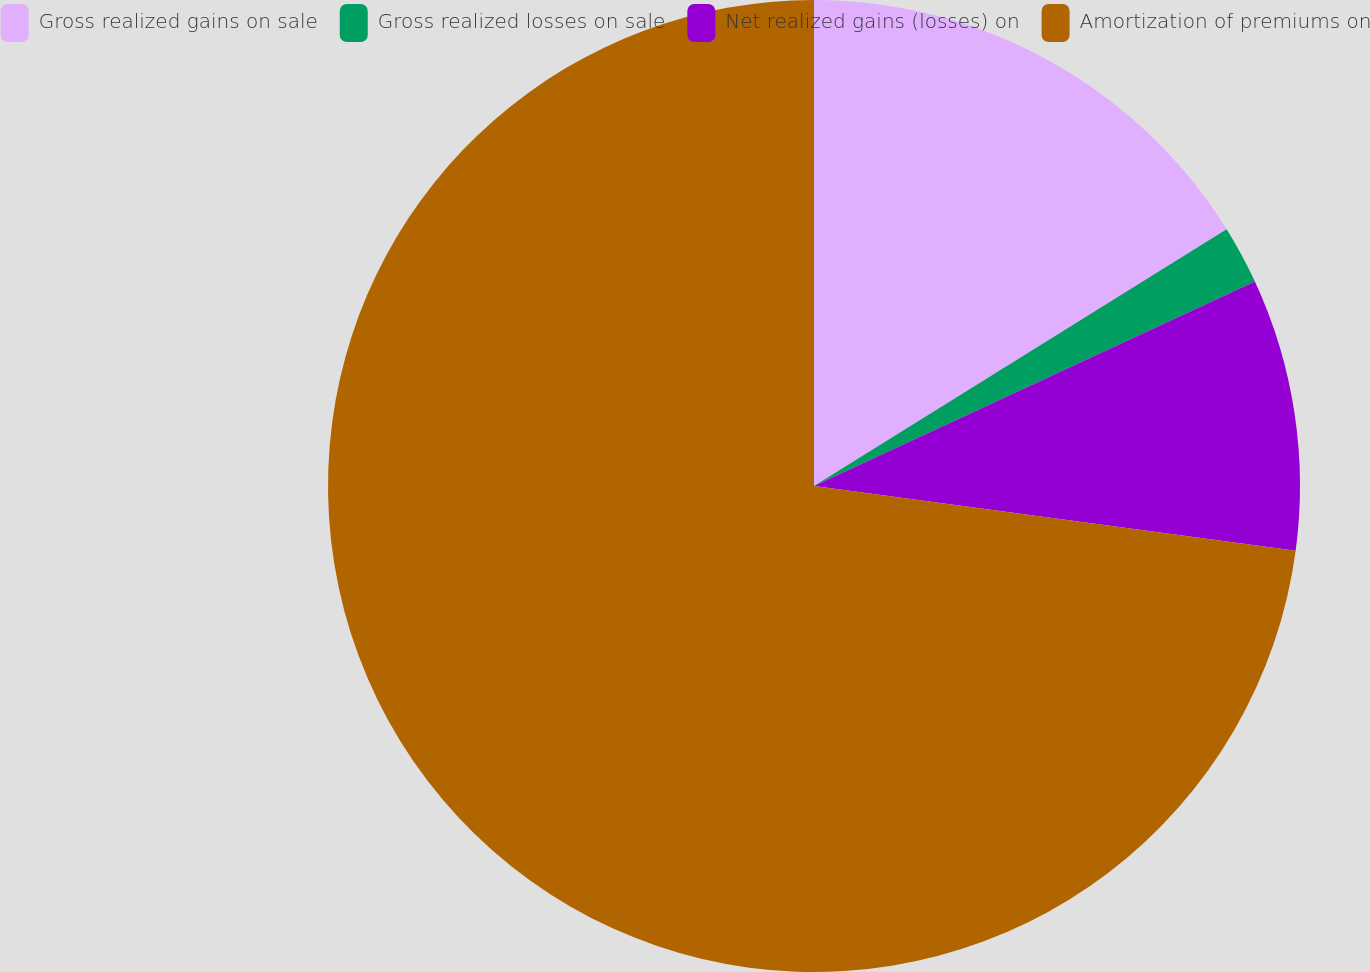<chart> <loc_0><loc_0><loc_500><loc_500><pie_chart><fcel>Gross realized gains on sale<fcel>Gross realized losses on sale<fcel>Net realized gains (losses) on<fcel>Amortization of premiums on<nl><fcel>16.14%<fcel>1.95%<fcel>9.04%<fcel>72.87%<nl></chart> 